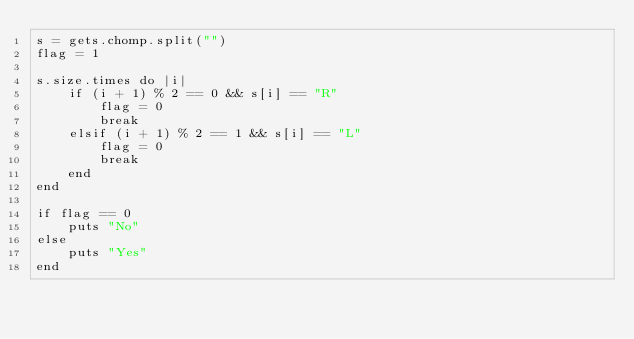<code> <loc_0><loc_0><loc_500><loc_500><_Ruby_>s = gets.chomp.split("")
flag = 1

s.size.times do |i|
    if (i + 1) % 2 == 0 && s[i] == "R"
        flag = 0
        break
    elsif (i + 1) % 2 == 1 && s[i] == "L"
        flag = 0
        break
    end
end

if flag == 0
    puts "No"
else
    puts "Yes"
end
</code> 